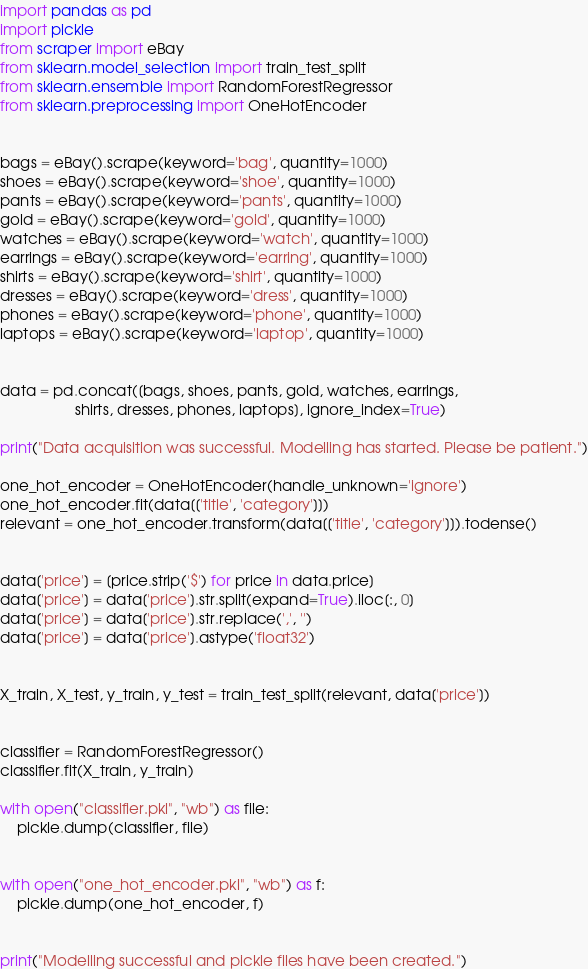Convert code to text. <code><loc_0><loc_0><loc_500><loc_500><_Python_>import pandas as pd
import pickle
from scraper import eBay
from sklearn.model_selection import train_test_split
from sklearn.ensemble import RandomForestRegressor
from sklearn.preprocessing import OneHotEncoder


bags = eBay().scrape(keyword='bag', quantity=1000)
shoes = eBay().scrape(keyword='shoe', quantity=1000)
pants = eBay().scrape(keyword='pants', quantity=1000)
gold = eBay().scrape(keyword='gold', quantity=1000)
watches = eBay().scrape(keyword='watch', quantity=1000)
earrings = eBay().scrape(keyword='earring', quantity=1000)
shirts = eBay().scrape(keyword='shirt', quantity=1000)
dresses = eBay().scrape(keyword='dress', quantity=1000)
phones = eBay().scrape(keyword='phone', quantity=1000)
laptops = eBay().scrape(keyword='laptop', quantity=1000)


data = pd.concat([bags, shoes, pants, gold, watches, earrings,
                  shirts, dresses, phones, laptops], ignore_index=True)

print("Data acquisition was successful. Modelling has started. Please be patient.")

one_hot_encoder = OneHotEncoder(handle_unknown='ignore')
one_hot_encoder.fit(data[['title', 'category']])
relevant = one_hot_encoder.transform(data[['title', 'category']]).todense()


data['price'] = [price.strip('$') for price in data.price]
data['price'] = data['price'].str.split(expand=True).iloc[:, 0]
data['price'] = data['price'].str.replace(',', '')
data['price'] = data['price'].astype('float32')


X_train, X_test, y_train, y_test = train_test_split(relevant, data['price'])


classifier = RandomForestRegressor()
classifier.fit(X_train, y_train)

with open("classifier.pkl", "wb") as file:
    pickle.dump(classifier, file)


with open("one_hot_encoder.pkl", "wb") as f:
    pickle.dump(one_hot_encoder, f)


print("Modelling successful and pickle files have been created.")
</code> 